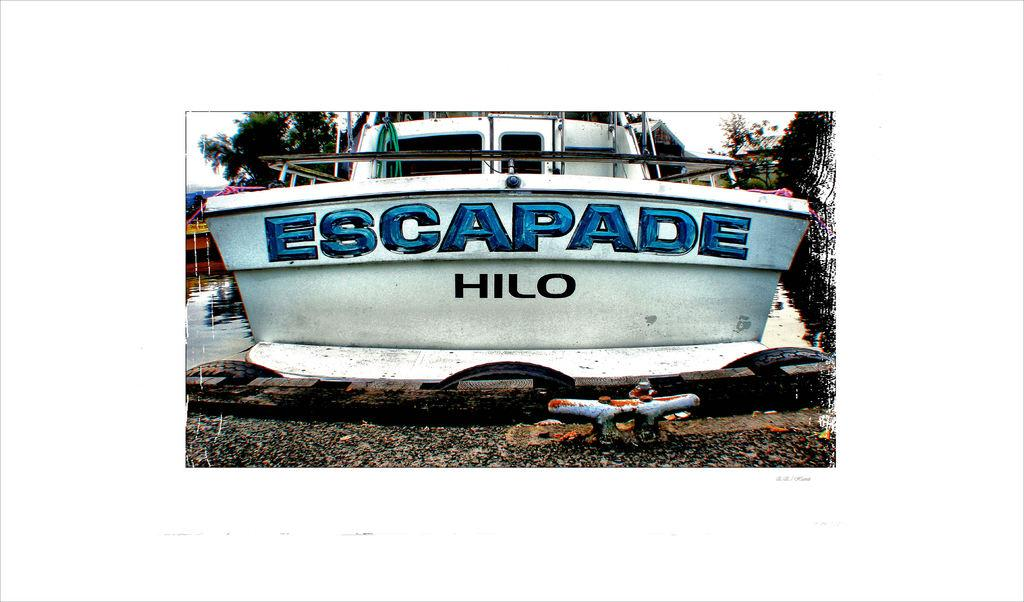Provide a one-sentence caption for the provided image. A boat on the water with the tagline Escapade Hilo. 